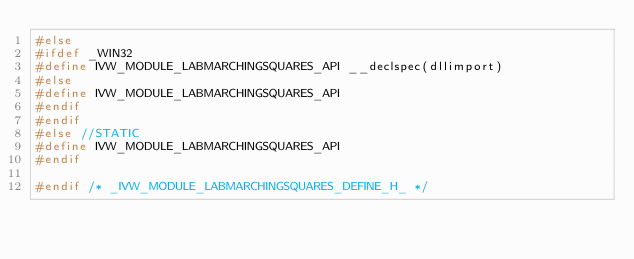Convert code to text. <code><loc_0><loc_0><loc_500><loc_500><_C_>#else
#ifdef _WIN32
#define IVW_MODULE_LABMARCHINGSQUARES_API __declspec(dllimport)
#else
#define IVW_MODULE_LABMARCHINGSQUARES_API
#endif
#endif
#else //STATIC
#define IVW_MODULE_LABMARCHINGSQUARES_API
#endif

#endif /* _IVW_MODULE_LABMARCHINGSQUARES_DEFINE_H_ */</code> 